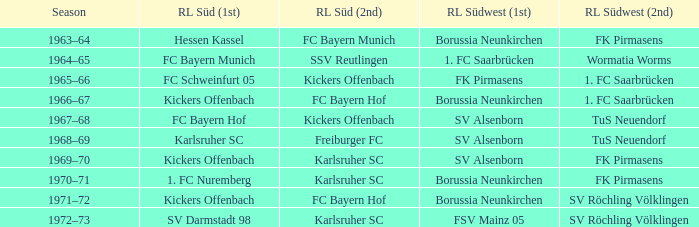What season was Freiburger FC the RL Süd (2nd) team? 1968–69. Parse the table in full. {'header': ['Season', 'RL Süd (1st)', 'RL Süd (2nd)', 'RL Südwest (1st)', 'RL Südwest (2nd)'], 'rows': [['1963–64', 'Hessen Kassel', 'FC Bayern Munich', 'Borussia Neunkirchen', 'FK Pirmasens'], ['1964–65', 'FC Bayern Munich', 'SSV Reutlingen', '1. FC Saarbrücken', 'Wormatia Worms'], ['1965–66', 'FC Schweinfurt 05', 'Kickers Offenbach', 'FK Pirmasens', '1. FC Saarbrücken'], ['1966–67', 'Kickers Offenbach', 'FC Bayern Hof', 'Borussia Neunkirchen', '1. FC Saarbrücken'], ['1967–68', 'FC Bayern Hof', 'Kickers Offenbach', 'SV Alsenborn', 'TuS Neuendorf'], ['1968–69', 'Karlsruher SC', 'Freiburger FC', 'SV Alsenborn', 'TuS Neuendorf'], ['1969–70', 'Kickers Offenbach', 'Karlsruher SC', 'SV Alsenborn', 'FK Pirmasens'], ['1970–71', '1. FC Nuremberg', 'Karlsruher SC', 'Borussia Neunkirchen', 'FK Pirmasens'], ['1971–72', 'Kickers Offenbach', 'FC Bayern Hof', 'Borussia Neunkirchen', 'SV Röchling Völklingen'], ['1972–73', 'SV Darmstadt 98', 'Karlsruher SC', 'FSV Mainz 05', 'SV Röchling Völklingen']]} 